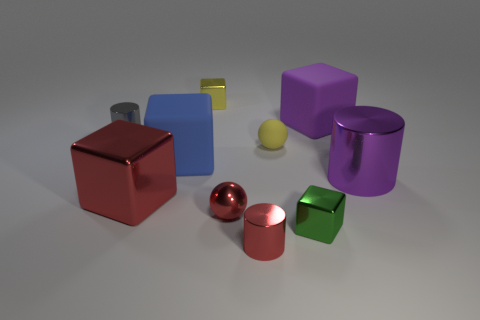What shape is the tiny yellow object that is right of the tiny red ball?
Ensure brevity in your answer.  Sphere. There is a small yellow object that is the same material as the large purple cylinder; what is its shape?
Keep it short and to the point. Cube. Is there anything else that has the same shape as the green metallic thing?
Your response must be concise. Yes. What number of shiny blocks are on the left side of the large red metal object?
Offer a terse response. 0. Are there the same number of purple metallic cylinders that are to the left of the purple shiny cylinder and small yellow blocks?
Keep it short and to the point. No. Is the material of the gray object the same as the blue object?
Make the answer very short. No. There is a metal object that is both to the right of the red cylinder and behind the tiny red shiny ball; what is its size?
Offer a very short reply. Large. How many other things have the same size as the gray shiny thing?
Provide a short and direct response. 5. There is a red object that is left of the large rubber thing left of the tiny yellow shiny thing; what is its size?
Ensure brevity in your answer.  Large. Does the purple object in front of the small matte sphere have the same shape as the big metal thing to the left of the yellow metal object?
Keep it short and to the point. No. 